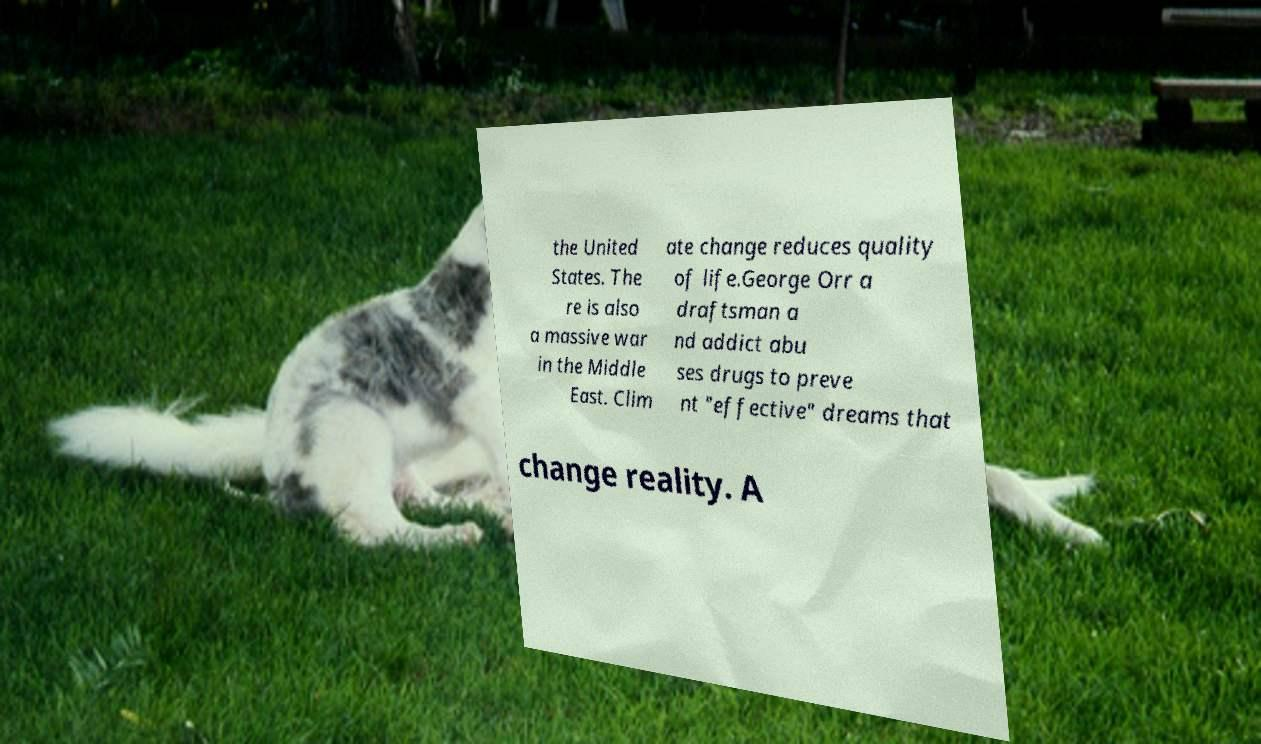Could you assist in decoding the text presented in this image and type it out clearly? the United States. The re is also a massive war in the Middle East. Clim ate change reduces quality of life.George Orr a draftsman a nd addict abu ses drugs to preve nt "effective" dreams that change reality. A 